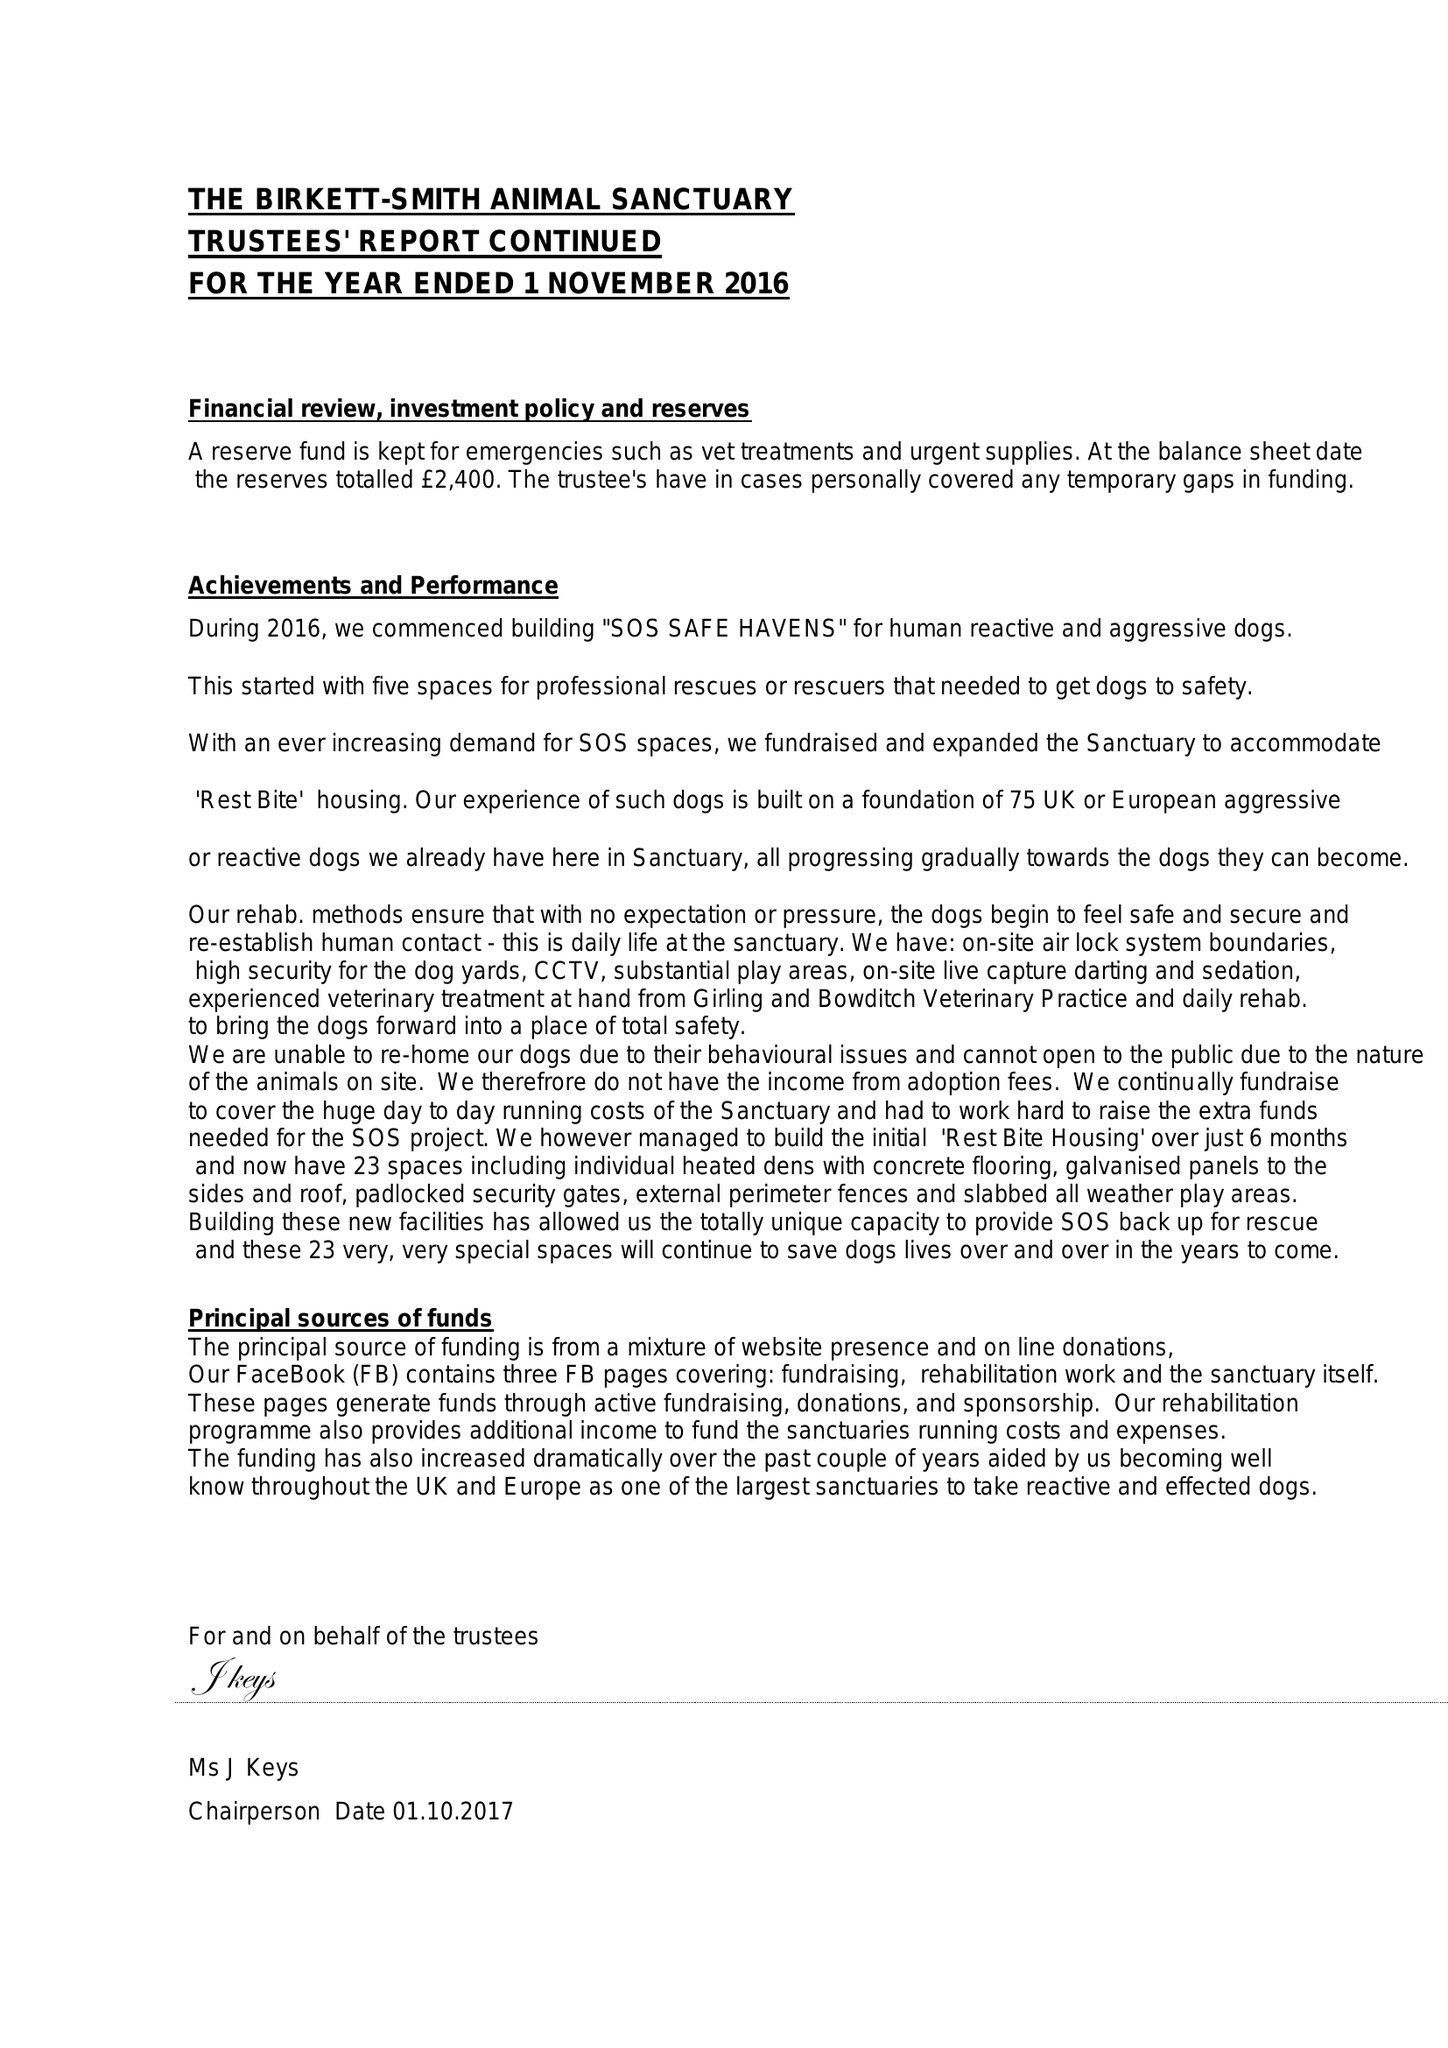What is the value for the address__street_line?
Answer the question using a single word or phrase. None 